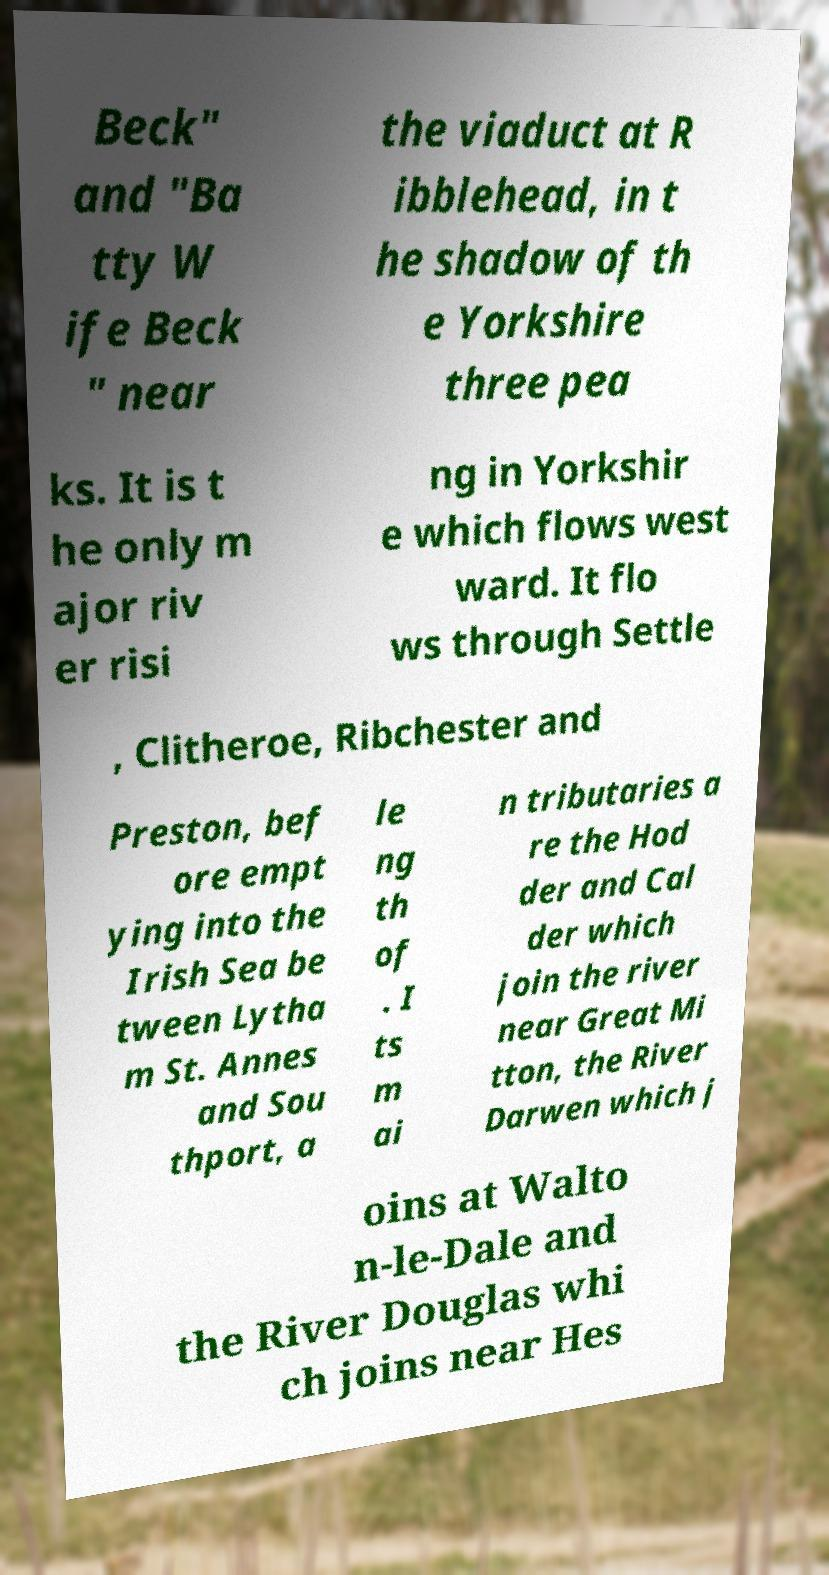What messages or text are displayed in this image? I need them in a readable, typed format. Beck" and "Ba tty W ife Beck " near the viaduct at R ibblehead, in t he shadow of th e Yorkshire three pea ks. It is t he only m ajor riv er risi ng in Yorkshir e which flows west ward. It flo ws through Settle , Clitheroe, Ribchester and Preston, bef ore empt ying into the Irish Sea be tween Lytha m St. Annes and Sou thport, a le ng th of . I ts m ai n tributaries a re the Hod der and Cal der which join the river near Great Mi tton, the River Darwen which j oins at Walto n-le-Dale and the River Douglas whi ch joins near Hes 